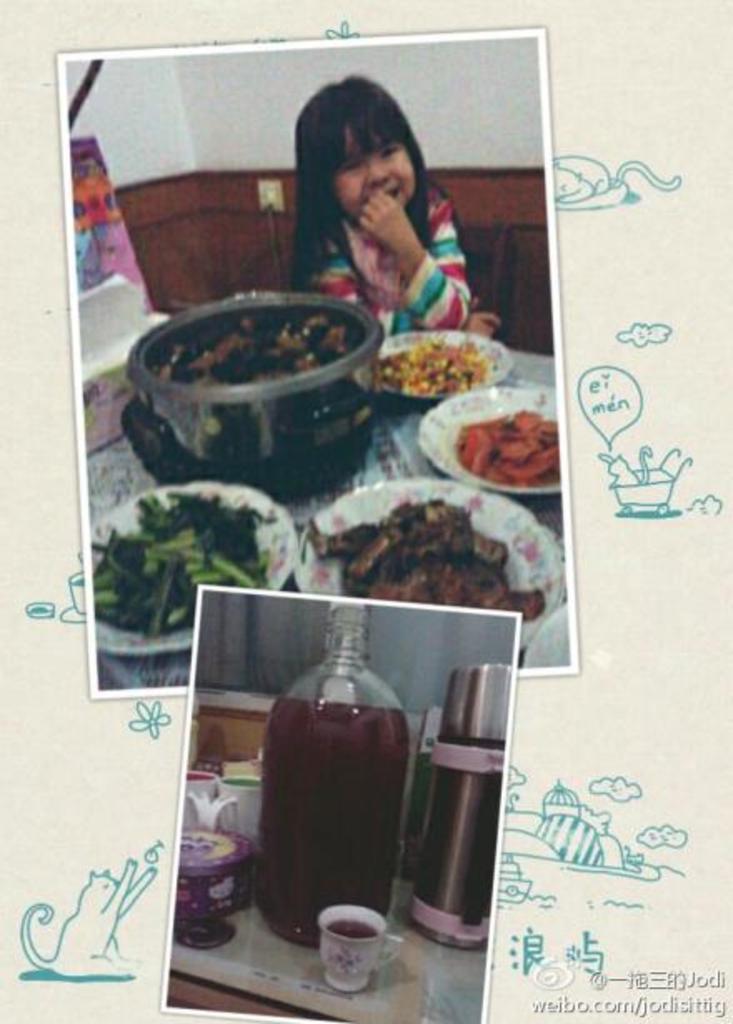In one or two sentences, can you explain what this image depicts? There are two images into collage. Of them one has a girl with some dishes in bowl and plates in front of her on a table. Other has a big glass jar with flask,cup and other containers around it on the table. 